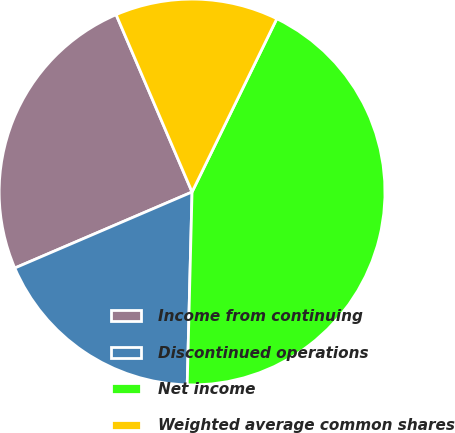Convert chart to OTSL. <chart><loc_0><loc_0><loc_500><loc_500><pie_chart><fcel>Income from continuing<fcel>Discontinued operations<fcel>Net income<fcel>Weighted average common shares<nl><fcel>25.01%<fcel>18.15%<fcel>43.16%<fcel>13.68%<nl></chart> 